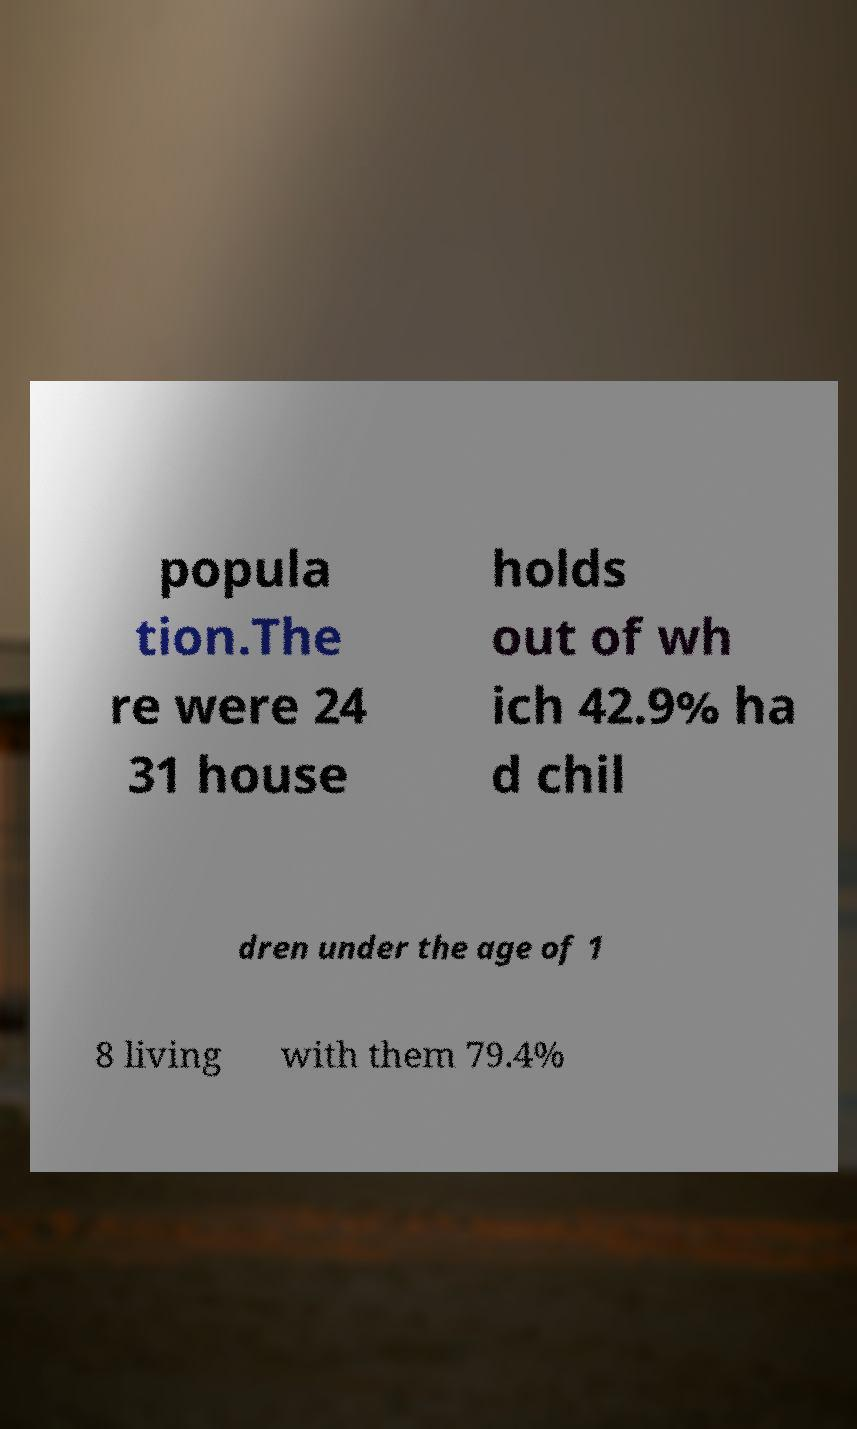Could you assist in decoding the text presented in this image and type it out clearly? popula tion.The re were 24 31 house holds out of wh ich 42.9% ha d chil dren under the age of 1 8 living with them 79.4% 